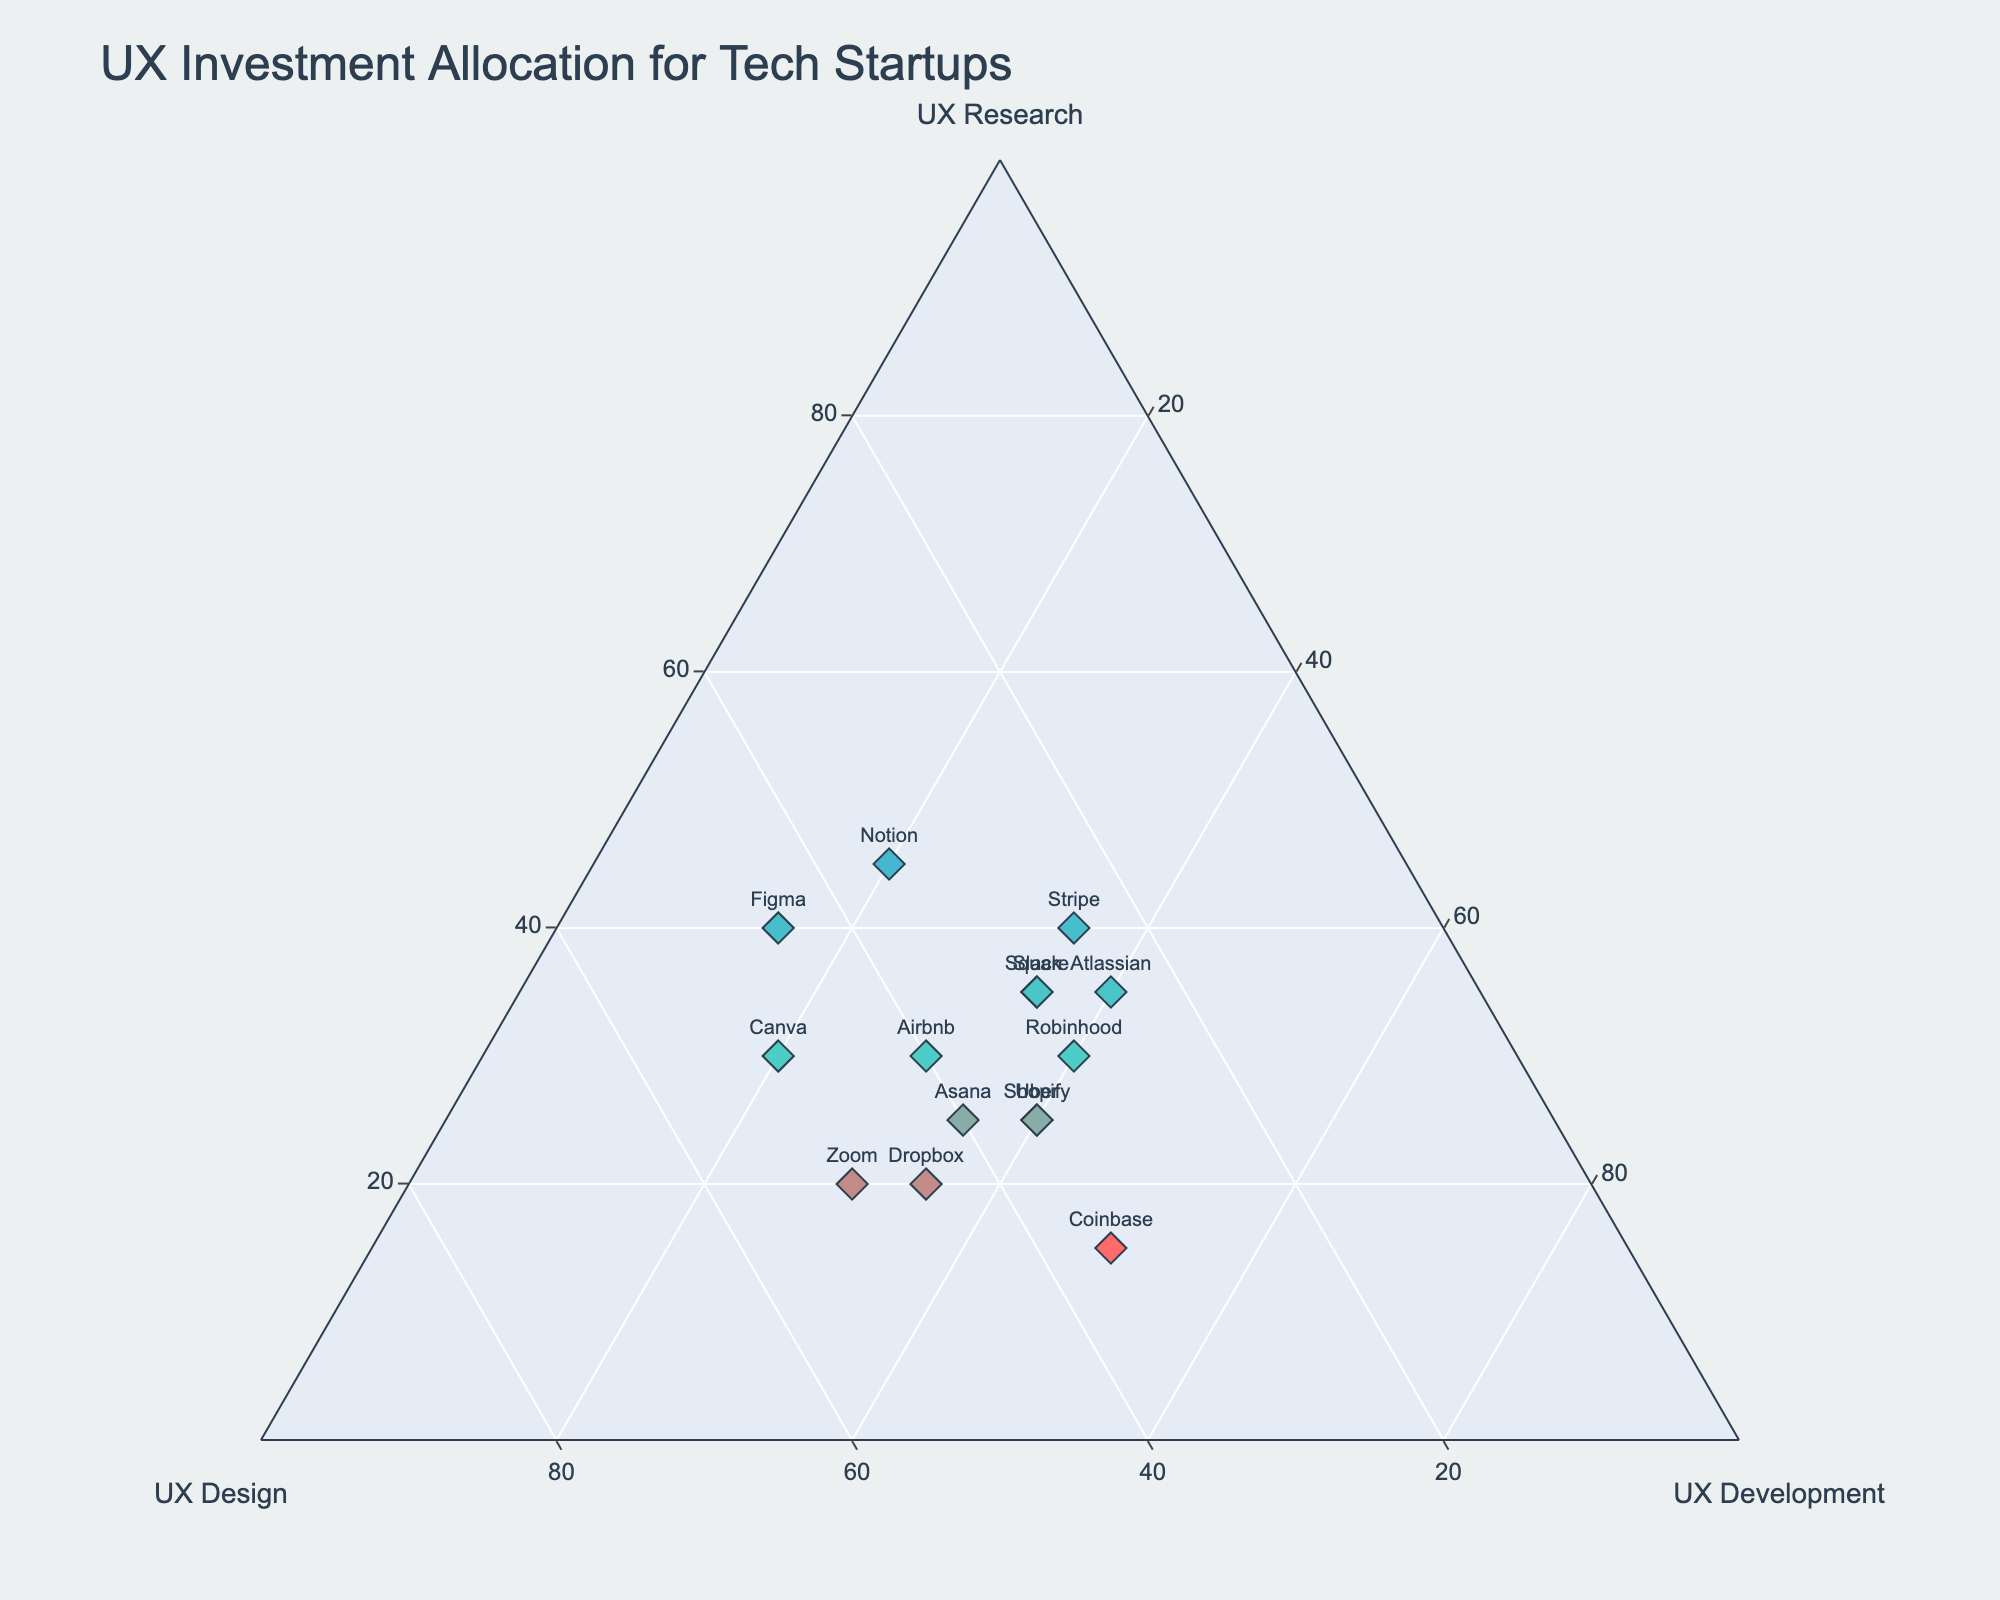How many companies are plotted in the ternary plot? Count the number of data points or labels displayed on the ternary plot. Each data point represents a company. There are 15 companies as per the given data.
Answer: 15 Which company has the highest allocation in UX Research? Look at the vertical axis labeled "UX Research." Find the data point that is closest to the top, which will have the highest percentage. According to the data, Notion has the highest allocation in UX Research.
Answer: Notion Which company has equal allocation across UX Research, UX Design, and UX Development? Find the intersection where all three axes (UX Research, UX Design, UX Development) values are equal. This would be near the center of the ternary plot. According to the data provided, there is no company with exactly equal allocations, but Slack is fairly balanced across the three areas.
Answer: None, but Slack is balanced What is the total allocation (sum) of UX Design for companies that allocate 30% UX Research? Identify companies with 30% allocation in UX Research and sum their UX Design allocations: Airbnb (40%), Robinhood (30%), and Canva (50%). Therefore, the total is 40 + 30 + 50 = 120.
Answer: 120 Which company allocates the least to UX Development, and what is the value? Look at the horizontal axis labeled "UX Development" and find the data point closest to the left edge, which represents the lowest percentage allocation. Figma allocates the least to UX Development with 15%.
Answer: Figma, 15% Which companies have a higher allocation in UX Research compared to UX Design? Compare the UX Research and UX Design allocations for each company and find those where UX Research > UX Design. According to the data, the companies are Stripe, Notion, Figma, and Atlassian.
Answer: Stripe, Notion, Figma, Atlassian What is the average allocation in UX Development for companies with the highest allocation in UX Design? Identify companies with the highest UX Design allocation (Canva, Zoom) and calculate their UX Development average. Canva (20%) and Zoom (30%). Therefore, average = (20 + 30) / 2 = 25.
Answer: 25 Which company allocates equally between UX Design and Development but differs from UX Research? Look for companies with UX Design equal to UX Development but differ significantly from UX Research. Asana allocates 40% to both UX Design and UX Development while differing from UX Research (25%).
Answer: Asana Which company shows the most balanced UX investment across all three areas, and what are the percentages? Look for a company whose data points are nearly equidistant from all three axes. Slack and Square both have balanced distribution with Slack at 35-30-35 and Square also at 35-30-35.
Answer: Slack, Square; 35-30-35 